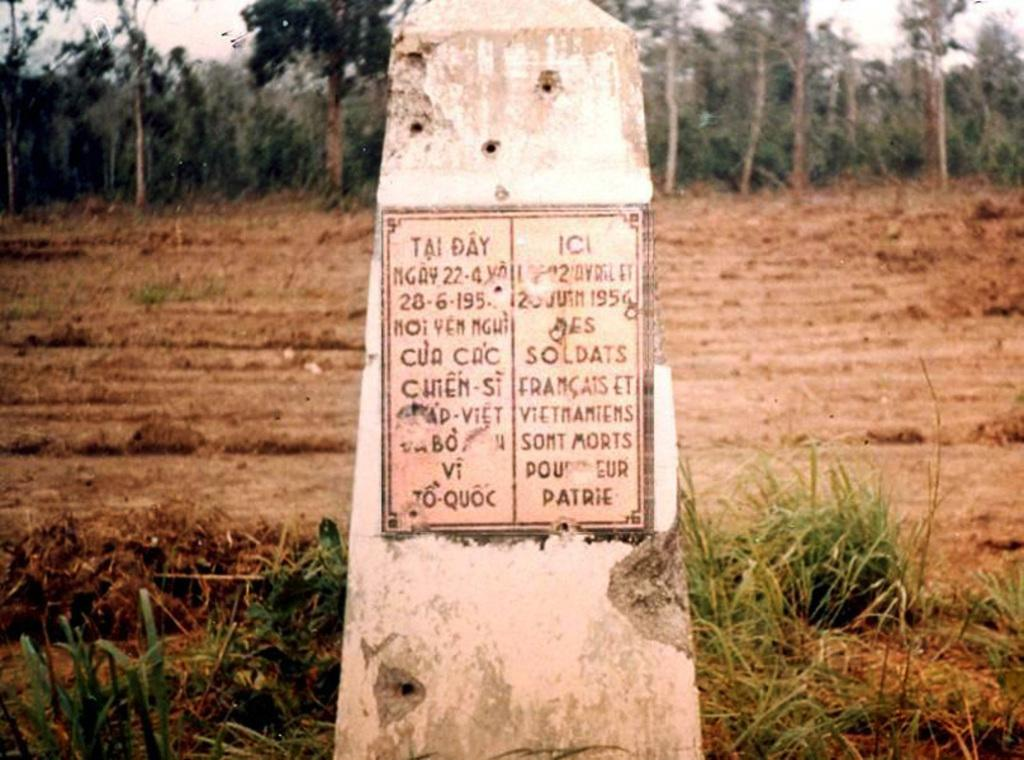What is the main subject of the image? There is a memorial stone in the image. Where is the memorial stone located? The memorial stone is on a piece of land. What can be seen in the background of the image? There are trees in the background of the image. What is the value of the debt owed by the memorial stone in the image? There is no mention of debt in the image, and the memorial stone is not capable of owing debt. 